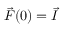Convert formula to latex. <formula><loc_0><loc_0><loc_500><loc_500>\vec { F } ( 0 ) = \vec { I }</formula> 